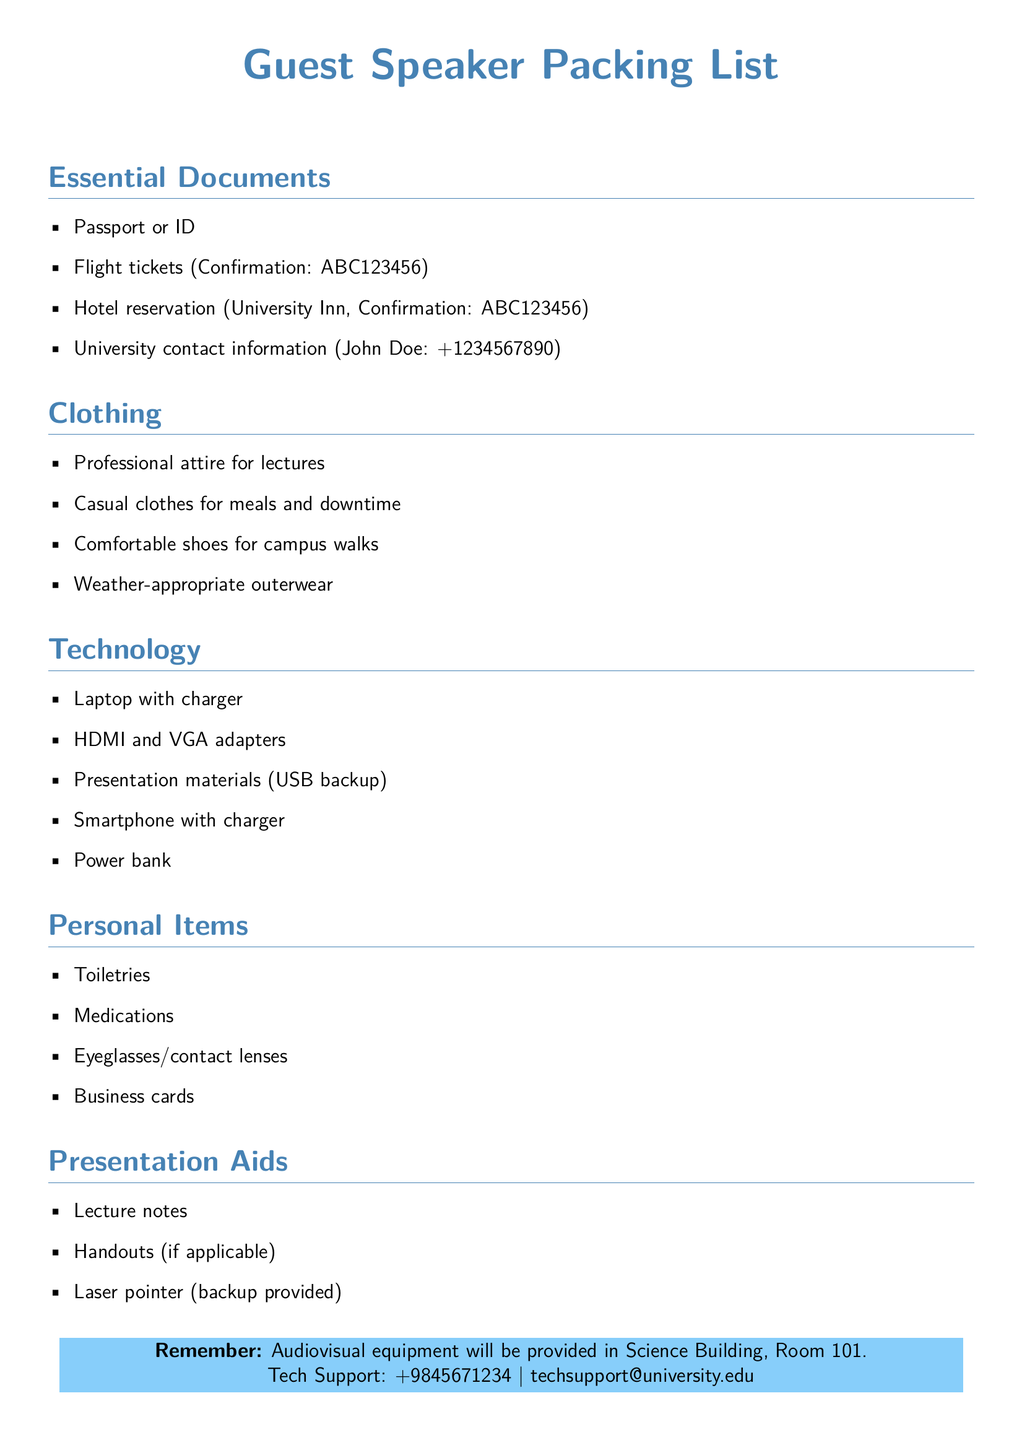What is the confirmation number for the flight tickets? The confirmation number for the flight tickets is clearly listed as ABC123456.
Answer: ABC123456 What type of attire is recommended for the speaker? The recommended attire is professional for lectures, as stated in the clothing section.
Answer: Professional attire Which room will the audiovisual equipment be provided in? The document specifically mentions that the equipment will be provided in Science Building, Room 101.
Answer: Science Building, Room 101 What is provided as a backup for the laser pointer? The document states that a backup laser pointer is provided, indicating extra support for the presentation.
Answer: Backup provided How many types of personal items are listed? The personal items section lists four unique items, focusing on essentials for personal care.
Answer: Four What is the university contact person's name? The contact person's name is mentioned in the essential documents, which identifies John Doe as the contact.
Answer: John Doe What color is used for the headings in the document? The headings are formatted in a specific color defined as maincolor within the document styling.
Answer: Maincolor 